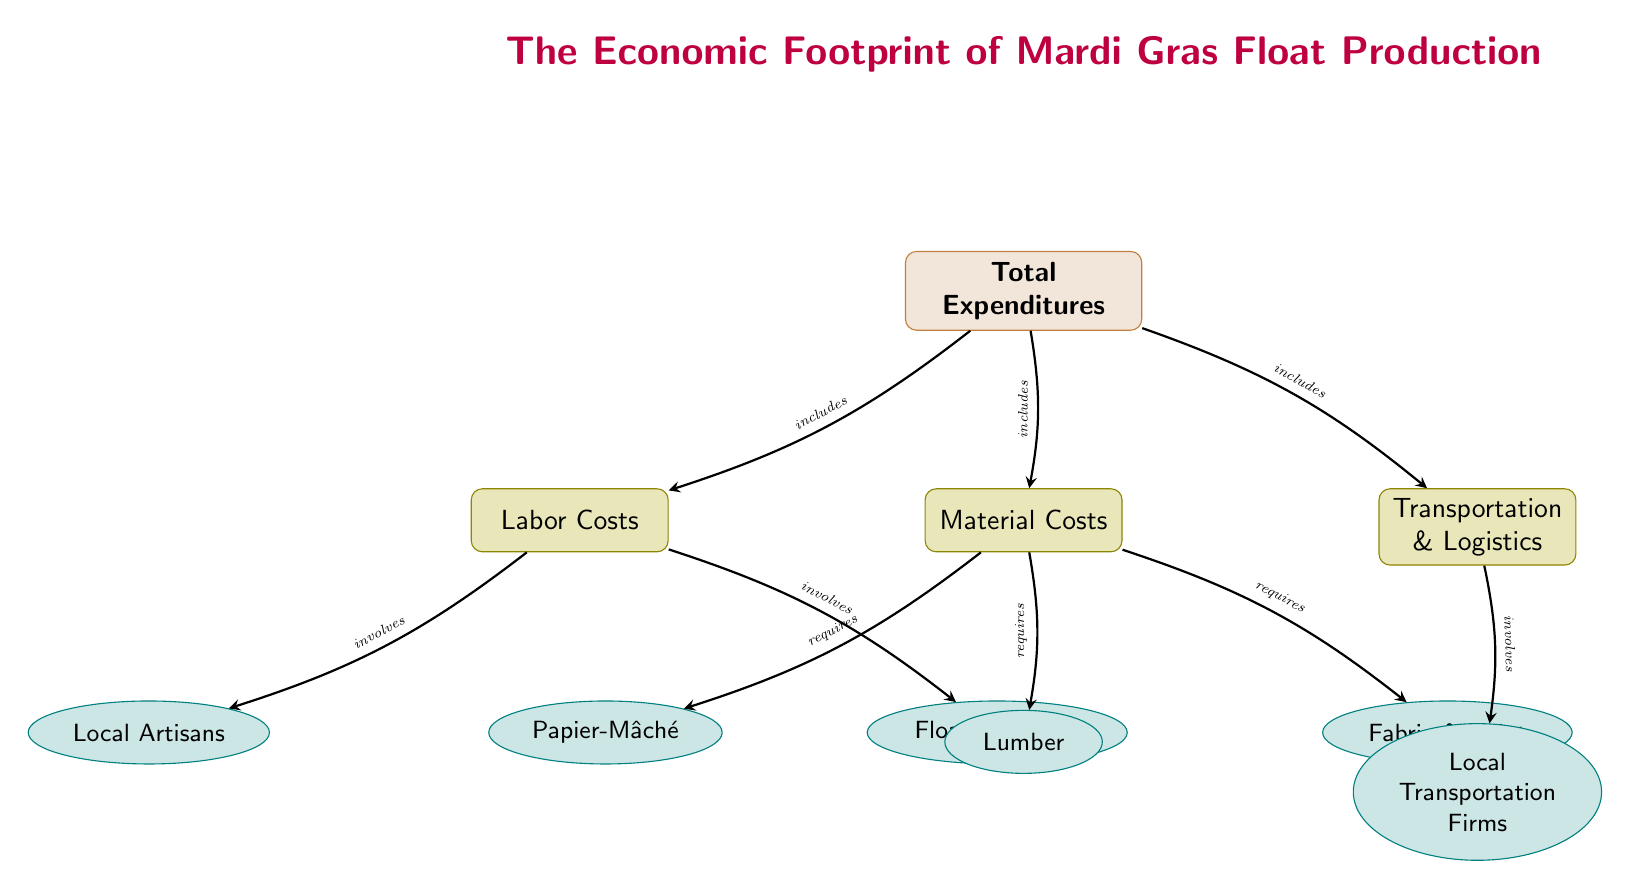What is the top node in the diagram? The top node is labeled "Total Expenditures," which represents the cumulative costs associated with Mardi Gras float production.
Answer: Total Expenditures How many subcategories are under Total Expenditures? There are three subcategories connected to the Total Expenditures node: Labor Costs, Material Costs, and Transportation & Logistics. The presence of three arrows pointing to each of these nodes indicates this relationship.
Answer: 3 Which node involves Local Artisans? The node "Labor Costs" involves Local Artisans, as it connects directly to this specific node, indicating that artisans are a contributing factor to labor expenses.
Answer: Labor Costs What materials are required for float production? The materials required for float production include Papier-Mâché, Lumber, and Fabric & Paint, all of which are connected directly under the Material Costs node.
Answer: Papier-Mâché, Lumber, Fabric & Paint Which node connects to Local Transportation Firms? The Transportation & Logistics node connects to the Local Transportation Firms node, indicating that these firms are involved in the transportation aspect of float production.
Answer: Transportation & Logistics Which category does the node "Float Designers" belong to? The node "Float Designers" belongs to the Labor Costs subcategory, as it is specifically linked to that node, indicating their role as contributors to labor.
Answer: Labor Costs What type of diagram is this? This is a Social Science Diagram, designed to illustrate the economic interactions and relationships within the context of Mardi Gras float production, emphasizing expenditures, labor, and material sourcing.
Answer: Social Science Diagram How many nodes are connected to Material Costs? There are three nodes connected to Material Costs, which are Papier-Mâché, Lumber, and Fabric & Paint, establishing the materials needed for float production.
Answer: 3 What role does the subcategory Transportation & Logistics play? The Transportation & Logistics subcategory details the costs associated with the transportation of materials and services, linked specifically to Local Transportation Firms.
Answer: Costs associated with transportation 